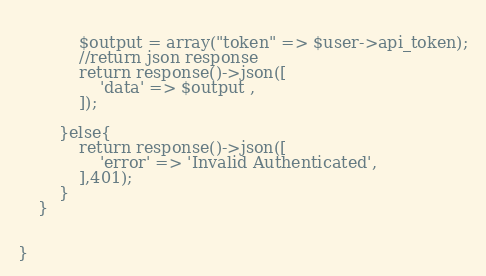<code> <loc_0><loc_0><loc_500><loc_500><_PHP_>            
            $output = array("token" => $user->api_token);
            //return json response
            return response()->json([
                'data' => $output ,
            ]);
           
        }else{
            return response()->json([
                'error' => 'Invalid Authenticated',
            ],401);
        }
    }
    

}


</code> 